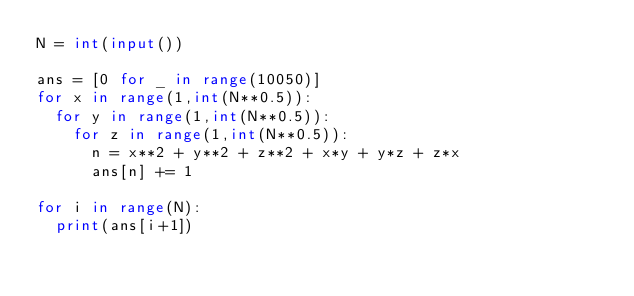Convert code to text. <code><loc_0><loc_0><loc_500><loc_500><_Python_>N = int(input())
 
ans = [0 for _ in range(10050)]
for x in range(1,int(N**0.5)):
  for y in range(1,int(N**0.5)):
    for z in range(1,int(N**0.5)):
      n = x**2 + y**2 + z**2 + x*y + y*z + z*x
      ans[n] += 1

for i in range(N):
  print(ans[i+1])</code> 